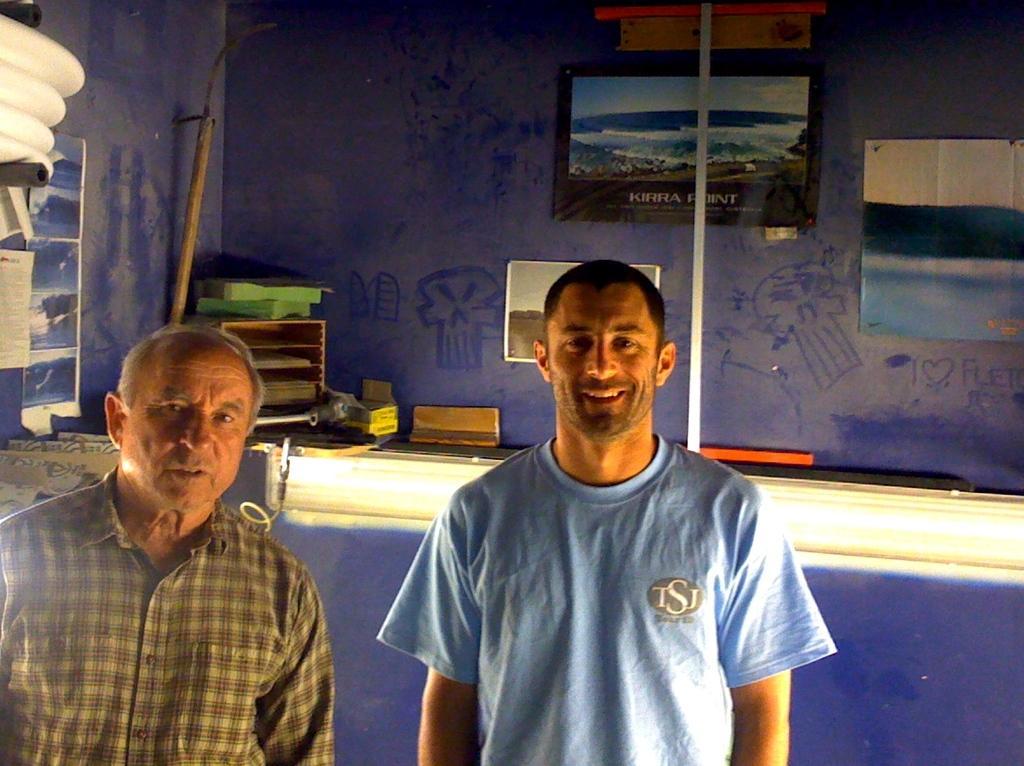In one or two sentences, can you explain what this image depicts? As we can see in the image there is a blue color wall, photo frames and two people standing in the front. The woman over here is wearing a blue color t shirt. 